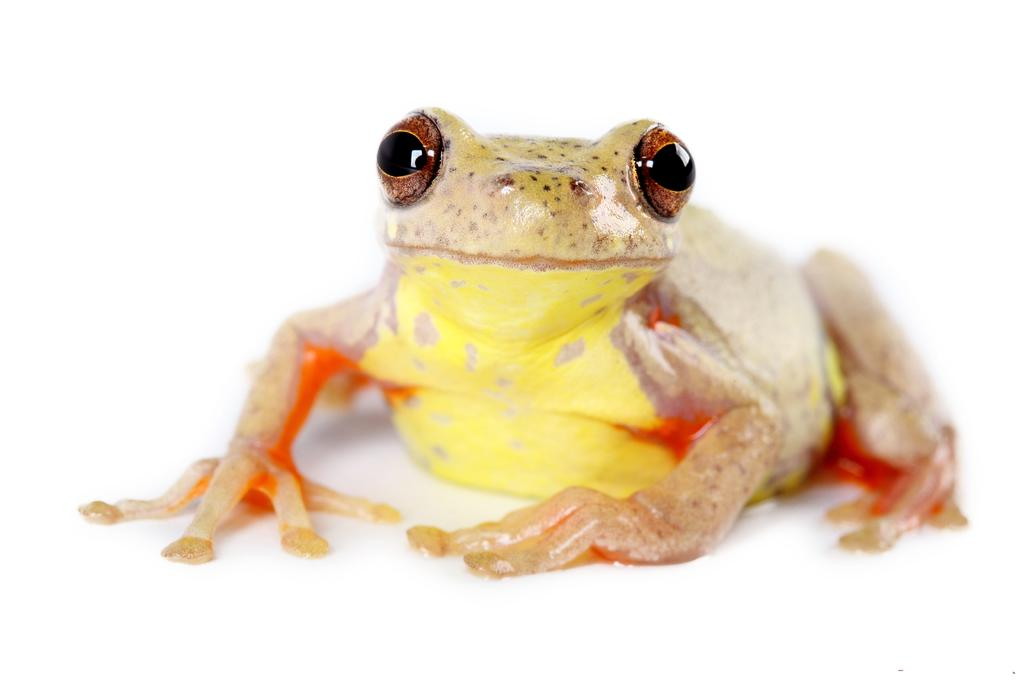What animal is present in the image? There is a frog in the image. What is the color of the frog? The frog is yellow and orange in color. What is the background of the image? The frog is on a white surface. What feature of the frog is particularly noticeable? The frog has big eyes. How many pizzas are hanging from the tree in the image? There are no pizzas or trees present in the image; it features a frog on a white surface. Can you describe the swing that the frog is using in the image? There is no swing present in the image; the frog is simply on a white surface. 